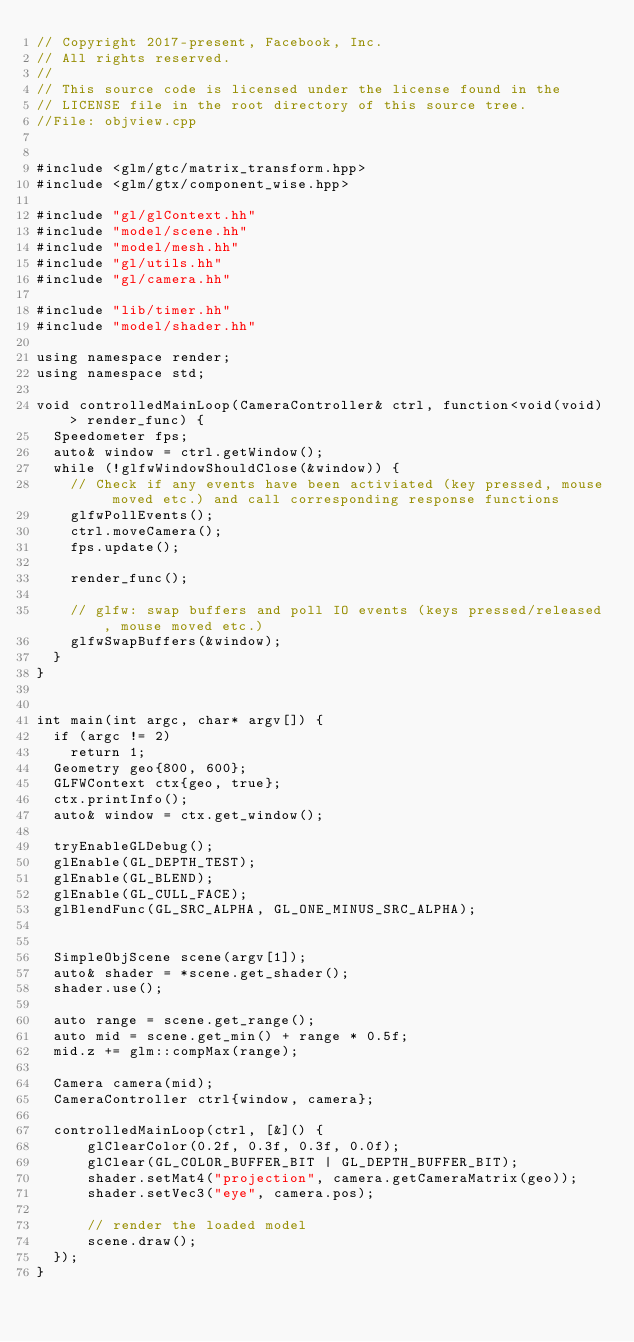Convert code to text. <code><loc_0><loc_0><loc_500><loc_500><_C++_>// Copyright 2017-present, Facebook, Inc.
// All rights reserved.
//
// This source code is licensed under the license found in the
// LICENSE file in the root directory of this source tree.
//File: objview.cpp


#include <glm/gtc/matrix_transform.hpp>
#include <glm/gtx/component_wise.hpp>

#include "gl/glContext.hh"
#include "model/scene.hh"
#include "model/mesh.hh"
#include "gl/utils.hh"
#include "gl/camera.hh"

#include "lib/timer.hh"
#include "model/shader.hh"

using namespace render;
using namespace std;

void controlledMainLoop(CameraController& ctrl, function<void(void)> render_func) {
  Speedometer fps;
  auto& window = ctrl.getWindow();
  while (!glfwWindowShouldClose(&window)) {
    // Check if any events have been activiated (key pressed, mouse moved etc.) and call corresponding response functions
    glfwPollEvents();
    ctrl.moveCamera();
    fps.update();

    render_func();

    // glfw: swap buffers and poll IO events (keys pressed/released, mouse moved etc.)
    glfwSwapBuffers(&window);
  }
}


int main(int argc, char* argv[]) {
  if (argc != 2)
    return 1;
  Geometry geo{800, 600};
  GLFWContext ctx{geo, true};
  ctx.printInfo();
  auto& window = ctx.get_window();

  tryEnableGLDebug();
  glEnable(GL_DEPTH_TEST);
  glEnable(GL_BLEND);
  glEnable(GL_CULL_FACE);
  glBlendFunc(GL_SRC_ALPHA, GL_ONE_MINUS_SRC_ALPHA);


  SimpleObjScene scene(argv[1]);
  auto& shader = *scene.get_shader();
  shader.use();

  auto range = scene.get_range();
  auto mid = scene.get_min() + range * 0.5f;
  mid.z += glm::compMax(range);

  Camera camera(mid);
  CameraController ctrl{window, camera};

  controlledMainLoop(ctrl, [&]() {
      glClearColor(0.2f, 0.3f, 0.3f, 0.0f);
      glClear(GL_COLOR_BUFFER_BIT | GL_DEPTH_BUFFER_BIT);
      shader.setMat4("projection", camera.getCameraMatrix(geo));
      shader.setVec3("eye", camera.pos);

      // render the loaded model
      scene.draw();
  });
}
</code> 